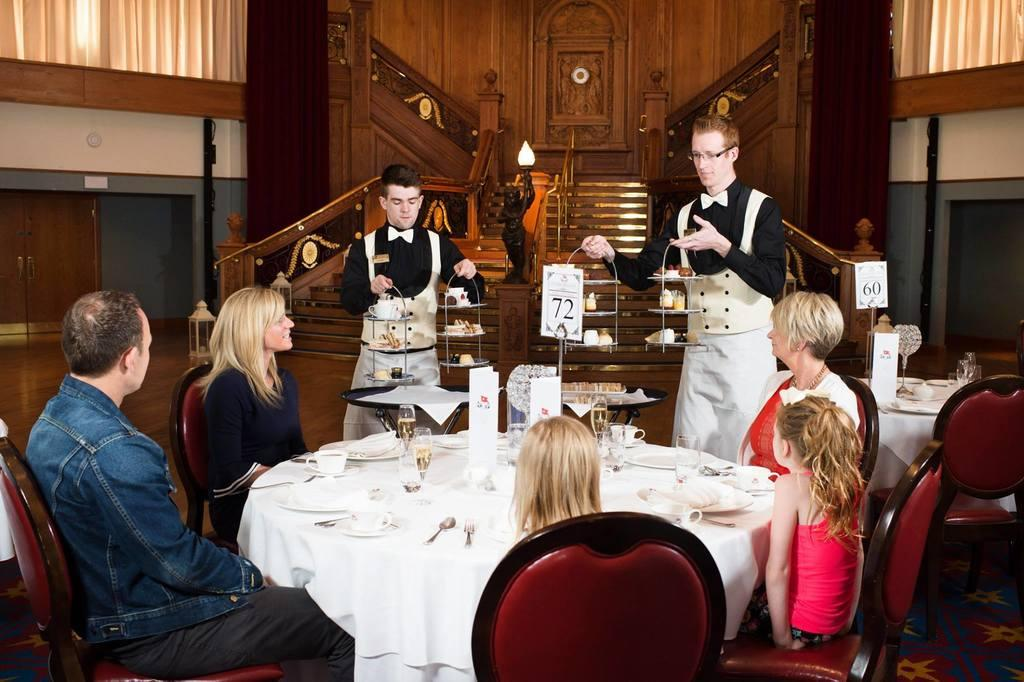What are the people in the image doing? The people in the image are sitting and standing. Where are the people gathered in the image? The people are gathered around a table. What can be seen in the background of the image? There is a building visible in the background of the image. What color is the board that the people are playing with in the image? There is no board present in the image, so it is not possible to determine its color. 